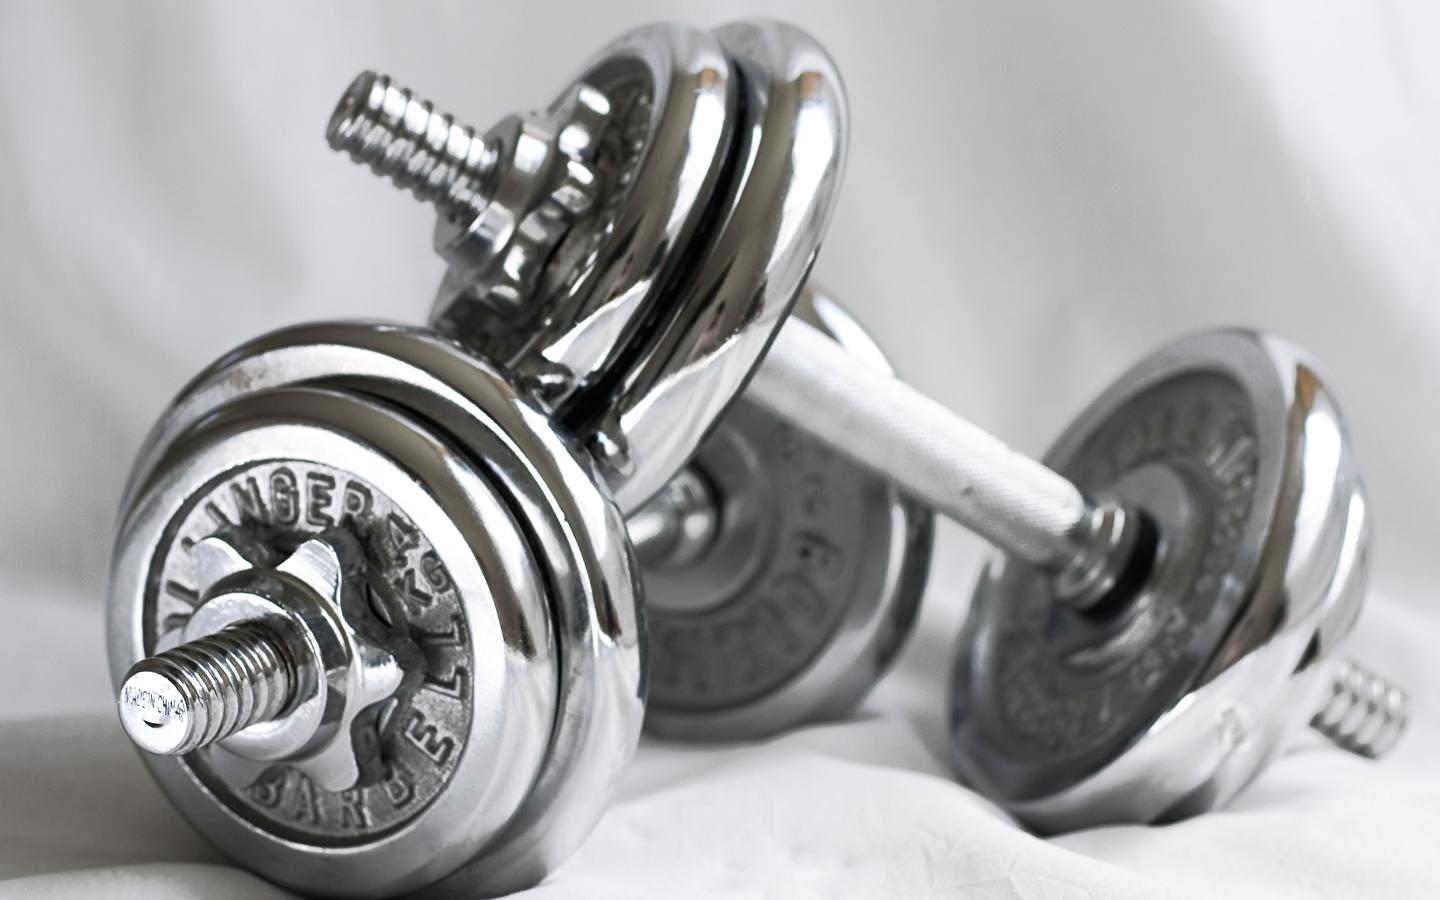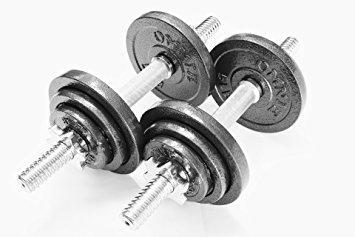The first image is the image on the left, the second image is the image on the right. Analyze the images presented: Is the assertion "One image shows a pair of small, matched dumbbells, with the end of one angled onto the bar of the other." valid? Answer yes or no. Yes. 